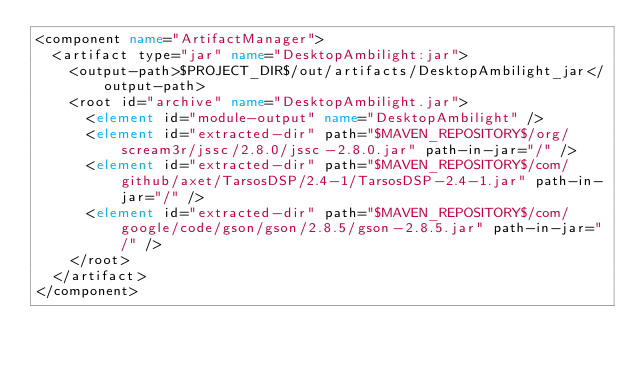Convert code to text. <code><loc_0><loc_0><loc_500><loc_500><_XML_><component name="ArtifactManager">
  <artifact type="jar" name="DesktopAmbilight:jar">
    <output-path>$PROJECT_DIR$/out/artifacts/DesktopAmbilight_jar</output-path>
    <root id="archive" name="DesktopAmbilight.jar">
      <element id="module-output" name="DesktopAmbilight" />
      <element id="extracted-dir" path="$MAVEN_REPOSITORY$/org/scream3r/jssc/2.8.0/jssc-2.8.0.jar" path-in-jar="/" />
      <element id="extracted-dir" path="$MAVEN_REPOSITORY$/com/github/axet/TarsosDSP/2.4-1/TarsosDSP-2.4-1.jar" path-in-jar="/" />
      <element id="extracted-dir" path="$MAVEN_REPOSITORY$/com/google/code/gson/gson/2.8.5/gson-2.8.5.jar" path-in-jar="/" />
    </root>
  </artifact>
</component></code> 